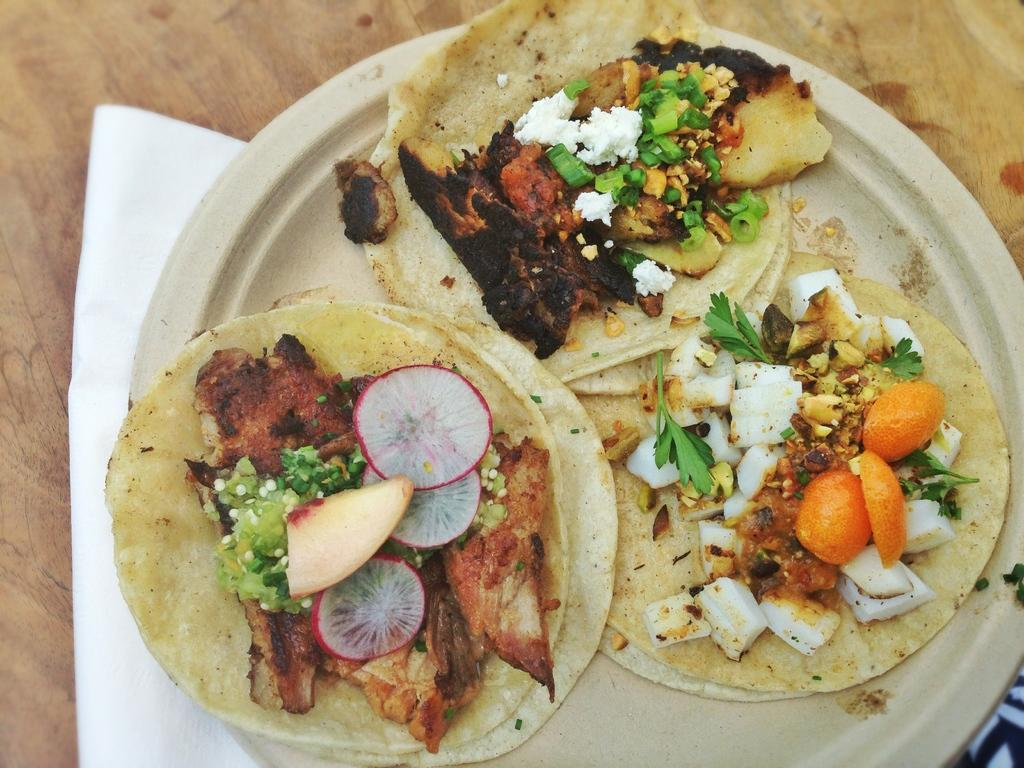What is the main food item visible in the image? There is a food item placed on a plate in the image. What additional item can be seen near the plate? There is a tissue beside the plate in the image. What substance is the food item made of in the image? The provided facts do not specify the substance or ingredients of the food item, so it cannot be determined from the image. 